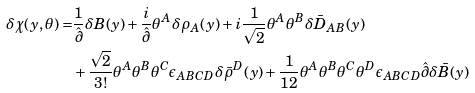Convert formula to latex. <formula><loc_0><loc_0><loc_500><loc_500>\delta \chi ( y , \theta ) = & \frac { 1 } { \hat { \partial } } \delta B ( y ) + \frac { i } { \hat { \partial } } \theta ^ { A } \delta \rho _ { A } ( y ) + i \frac { 1 } { \sqrt { 2 } } \theta ^ { A } \theta ^ { B } \delta \bar { D } _ { A B } ( y ) \\ & + \frac { \sqrt { 2 } } { 3 ! } \theta ^ { A } \theta ^ { B } \theta ^ { C } \epsilon _ { A B C D } \delta \bar { \rho } ^ { D } ( y ) + \frac { 1 } { 1 2 } \theta ^ { A } \theta ^ { B } \theta ^ { C } \theta ^ { D } \epsilon _ { A B C D } \hat { \partial } \delta \bar { B } ( y )</formula> 